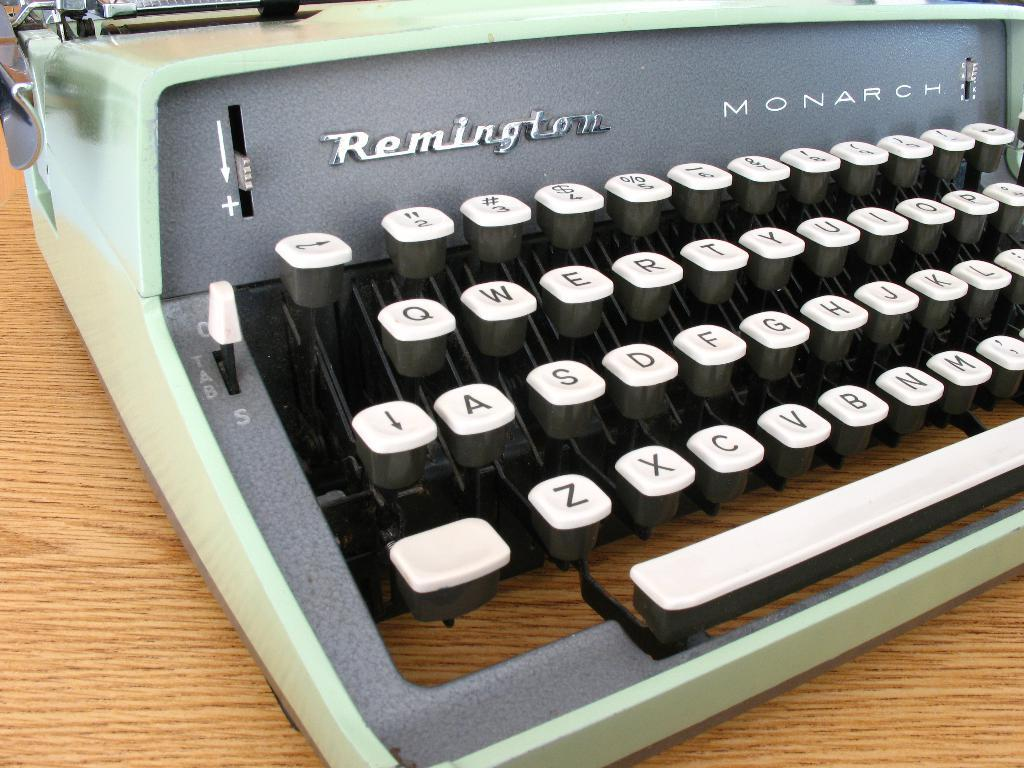<image>
Present a compact description of the photo's key features. An old Remington Monarch typewriter with a qwerty keyboard. 